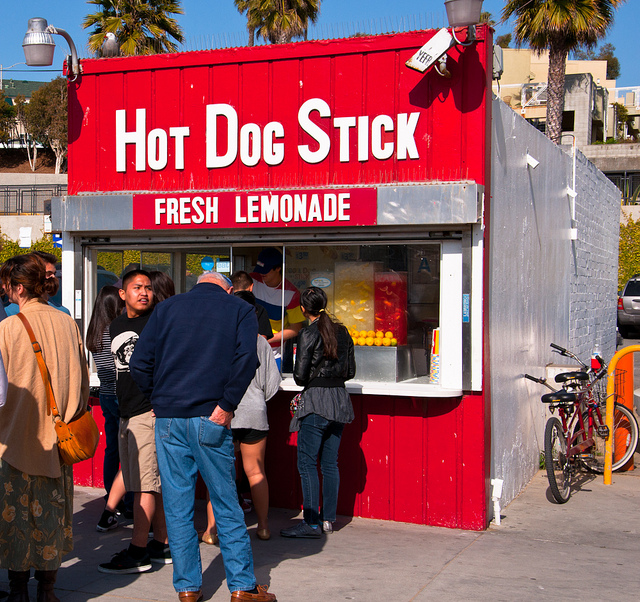<image>Who owns the sausage stand? I don't know who owns the sausage stand. It could be a man, mike, or a shopkeeper. Who owns the sausage stand? I don't know who owns the sausage stand. It could be someone or an unknown person. 